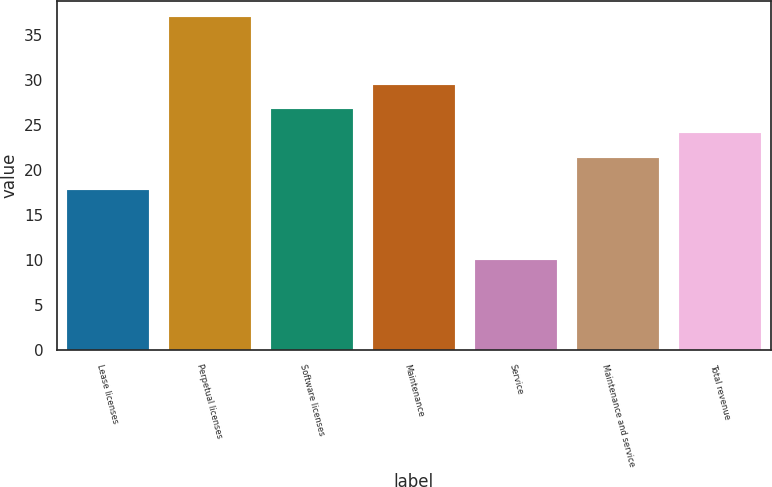<chart> <loc_0><loc_0><loc_500><loc_500><bar_chart><fcel>Lease licenses<fcel>Perpetual licenses<fcel>Software licenses<fcel>Maintenance<fcel>Service<fcel>Maintenance and service<fcel>Total revenue<nl><fcel>17.8<fcel>37<fcel>26.8<fcel>29.5<fcel>10<fcel>21.3<fcel>24.1<nl></chart> 